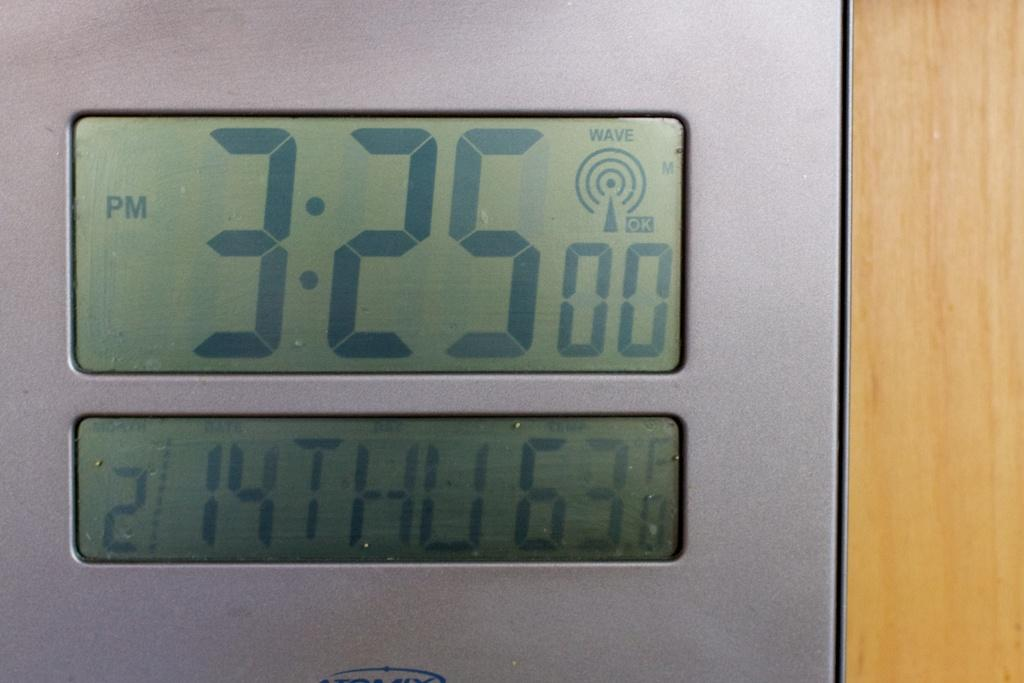<image>
Offer a succinct explanation of the picture presented. The clock says 3:25 pm on 2/14 Thursday 